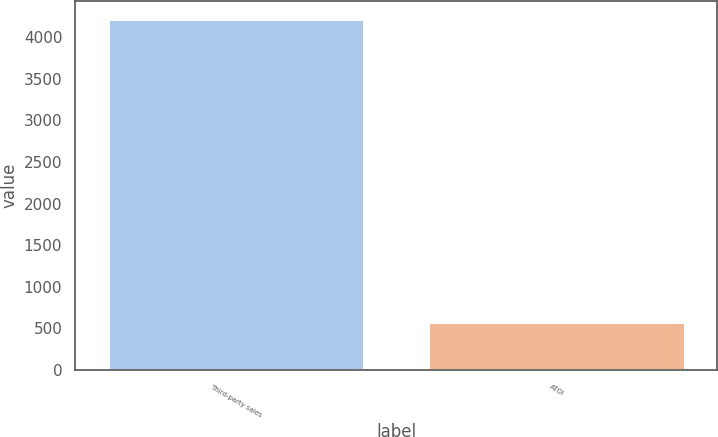<chart> <loc_0><loc_0><loc_500><loc_500><bar_chart><fcel>Third-party sales<fcel>ATOI<nl><fcel>4217<fcel>579<nl></chart> 